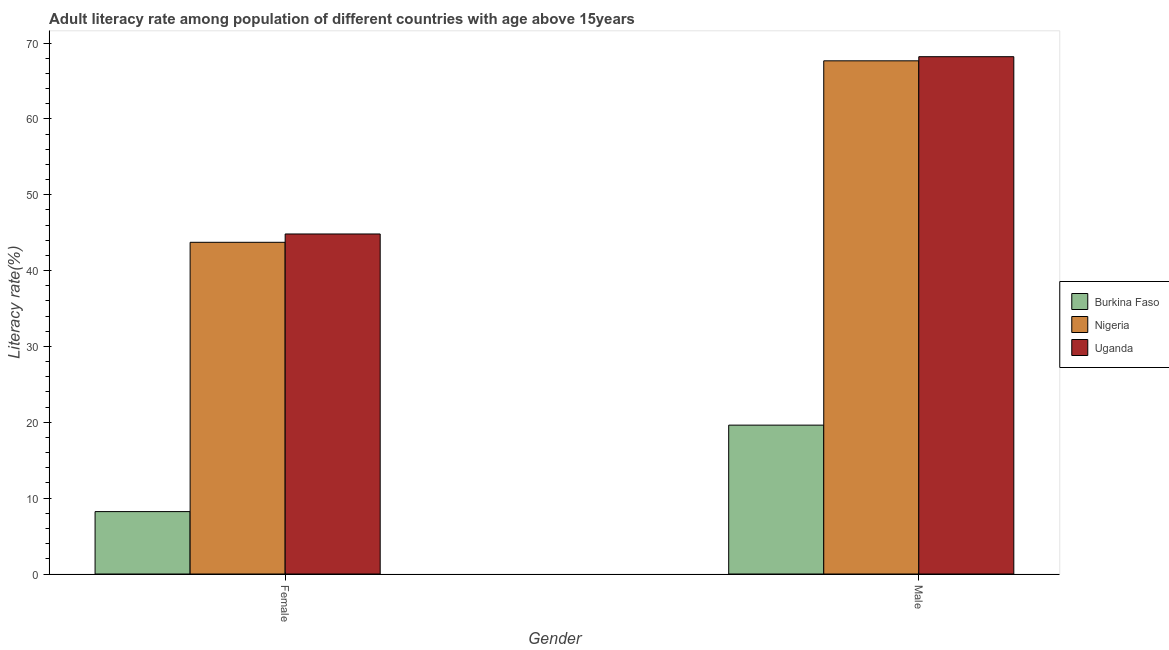How many groups of bars are there?
Provide a short and direct response. 2. Are the number of bars per tick equal to the number of legend labels?
Provide a short and direct response. Yes. Are the number of bars on each tick of the X-axis equal?
Keep it short and to the point. Yes. How many bars are there on the 1st tick from the left?
Give a very brief answer. 3. What is the label of the 2nd group of bars from the left?
Your answer should be compact. Male. What is the female adult literacy rate in Uganda?
Your response must be concise. 44.83. Across all countries, what is the maximum female adult literacy rate?
Keep it short and to the point. 44.83. Across all countries, what is the minimum female adult literacy rate?
Make the answer very short. 8.23. In which country was the male adult literacy rate maximum?
Your answer should be compact. Uganda. In which country was the male adult literacy rate minimum?
Your answer should be compact. Burkina Faso. What is the total male adult literacy rate in the graph?
Keep it short and to the point. 155.48. What is the difference between the male adult literacy rate in Burkina Faso and that in Uganda?
Your response must be concise. -48.57. What is the difference between the male adult literacy rate in Uganda and the female adult literacy rate in Nigeria?
Ensure brevity in your answer.  24.47. What is the average male adult literacy rate per country?
Ensure brevity in your answer.  51.83. What is the difference between the female adult literacy rate and male adult literacy rate in Nigeria?
Your answer should be very brief. -23.92. In how many countries, is the female adult literacy rate greater than 40 %?
Offer a terse response. 2. What is the ratio of the male adult literacy rate in Nigeria to that in Uganda?
Provide a short and direct response. 0.99. What does the 2nd bar from the left in Male represents?
Give a very brief answer. Nigeria. What does the 1st bar from the right in Female represents?
Keep it short and to the point. Uganda. How many countries are there in the graph?
Provide a succinct answer. 3. Are the values on the major ticks of Y-axis written in scientific E-notation?
Your response must be concise. No. Does the graph contain any zero values?
Your answer should be very brief. No. How many legend labels are there?
Your answer should be compact. 3. How are the legend labels stacked?
Ensure brevity in your answer.  Vertical. What is the title of the graph?
Give a very brief answer. Adult literacy rate among population of different countries with age above 15years. Does "Sint Maarten (Dutch part)" appear as one of the legend labels in the graph?
Offer a very short reply. No. What is the label or title of the X-axis?
Your answer should be compact. Gender. What is the label or title of the Y-axis?
Offer a very short reply. Literacy rate(%). What is the Literacy rate(%) in Burkina Faso in Female?
Give a very brief answer. 8.23. What is the Literacy rate(%) in Nigeria in Female?
Keep it short and to the point. 43.73. What is the Literacy rate(%) in Uganda in Female?
Offer a very short reply. 44.83. What is the Literacy rate(%) of Burkina Faso in Male?
Your answer should be very brief. 19.63. What is the Literacy rate(%) of Nigeria in Male?
Your answer should be very brief. 67.65. What is the Literacy rate(%) in Uganda in Male?
Give a very brief answer. 68.2. Across all Gender, what is the maximum Literacy rate(%) in Burkina Faso?
Make the answer very short. 19.63. Across all Gender, what is the maximum Literacy rate(%) of Nigeria?
Give a very brief answer. 67.65. Across all Gender, what is the maximum Literacy rate(%) of Uganda?
Offer a very short reply. 68.2. Across all Gender, what is the minimum Literacy rate(%) in Burkina Faso?
Offer a terse response. 8.23. Across all Gender, what is the minimum Literacy rate(%) in Nigeria?
Give a very brief answer. 43.73. Across all Gender, what is the minimum Literacy rate(%) of Uganda?
Your answer should be compact. 44.83. What is the total Literacy rate(%) in Burkina Faso in the graph?
Ensure brevity in your answer.  27.85. What is the total Literacy rate(%) of Nigeria in the graph?
Provide a short and direct response. 111.38. What is the total Literacy rate(%) of Uganda in the graph?
Provide a succinct answer. 113.02. What is the difference between the Literacy rate(%) in Burkina Faso in Female and that in Male?
Offer a terse response. -11.4. What is the difference between the Literacy rate(%) in Nigeria in Female and that in Male?
Your answer should be compact. -23.92. What is the difference between the Literacy rate(%) of Uganda in Female and that in Male?
Offer a terse response. -23.37. What is the difference between the Literacy rate(%) of Burkina Faso in Female and the Literacy rate(%) of Nigeria in Male?
Your answer should be compact. -59.43. What is the difference between the Literacy rate(%) in Burkina Faso in Female and the Literacy rate(%) in Uganda in Male?
Make the answer very short. -59.97. What is the difference between the Literacy rate(%) of Nigeria in Female and the Literacy rate(%) of Uganda in Male?
Make the answer very short. -24.47. What is the average Literacy rate(%) of Burkina Faso per Gender?
Provide a short and direct response. 13.93. What is the average Literacy rate(%) in Nigeria per Gender?
Your answer should be very brief. 55.69. What is the average Literacy rate(%) in Uganda per Gender?
Your answer should be compact. 56.51. What is the difference between the Literacy rate(%) of Burkina Faso and Literacy rate(%) of Nigeria in Female?
Offer a very short reply. -35.5. What is the difference between the Literacy rate(%) in Burkina Faso and Literacy rate(%) in Uganda in Female?
Your response must be concise. -36.6. What is the difference between the Literacy rate(%) of Nigeria and Literacy rate(%) of Uganda in Female?
Your answer should be very brief. -1.1. What is the difference between the Literacy rate(%) in Burkina Faso and Literacy rate(%) in Nigeria in Male?
Your answer should be very brief. -48.03. What is the difference between the Literacy rate(%) in Burkina Faso and Literacy rate(%) in Uganda in Male?
Keep it short and to the point. -48.57. What is the difference between the Literacy rate(%) of Nigeria and Literacy rate(%) of Uganda in Male?
Offer a terse response. -0.54. What is the ratio of the Literacy rate(%) in Burkina Faso in Female to that in Male?
Give a very brief answer. 0.42. What is the ratio of the Literacy rate(%) of Nigeria in Female to that in Male?
Keep it short and to the point. 0.65. What is the ratio of the Literacy rate(%) in Uganda in Female to that in Male?
Your answer should be very brief. 0.66. What is the difference between the highest and the second highest Literacy rate(%) in Burkina Faso?
Ensure brevity in your answer.  11.4. What is the difference between the highest and the second highest Literacy rate(%) in Nigeria?
Ensure brevity in your answer.  23.92. What is the difference between the highest and the second highest Literacy rate(%) in Uganda?
Your answer should be compact. 23.37. What is the difference between the highest and the lowest Literacy rate(%) of Burkina Faso?
Give a very brief answer. 11.4. What is the difference between the highest and the lowest Literacy rate(%) in Nigeria?
Your response must be concise. 23.92. What is the difference between the highest and the lowest Literacy rate(%) of Uganda?
Give a very brief answer. 23.37. 